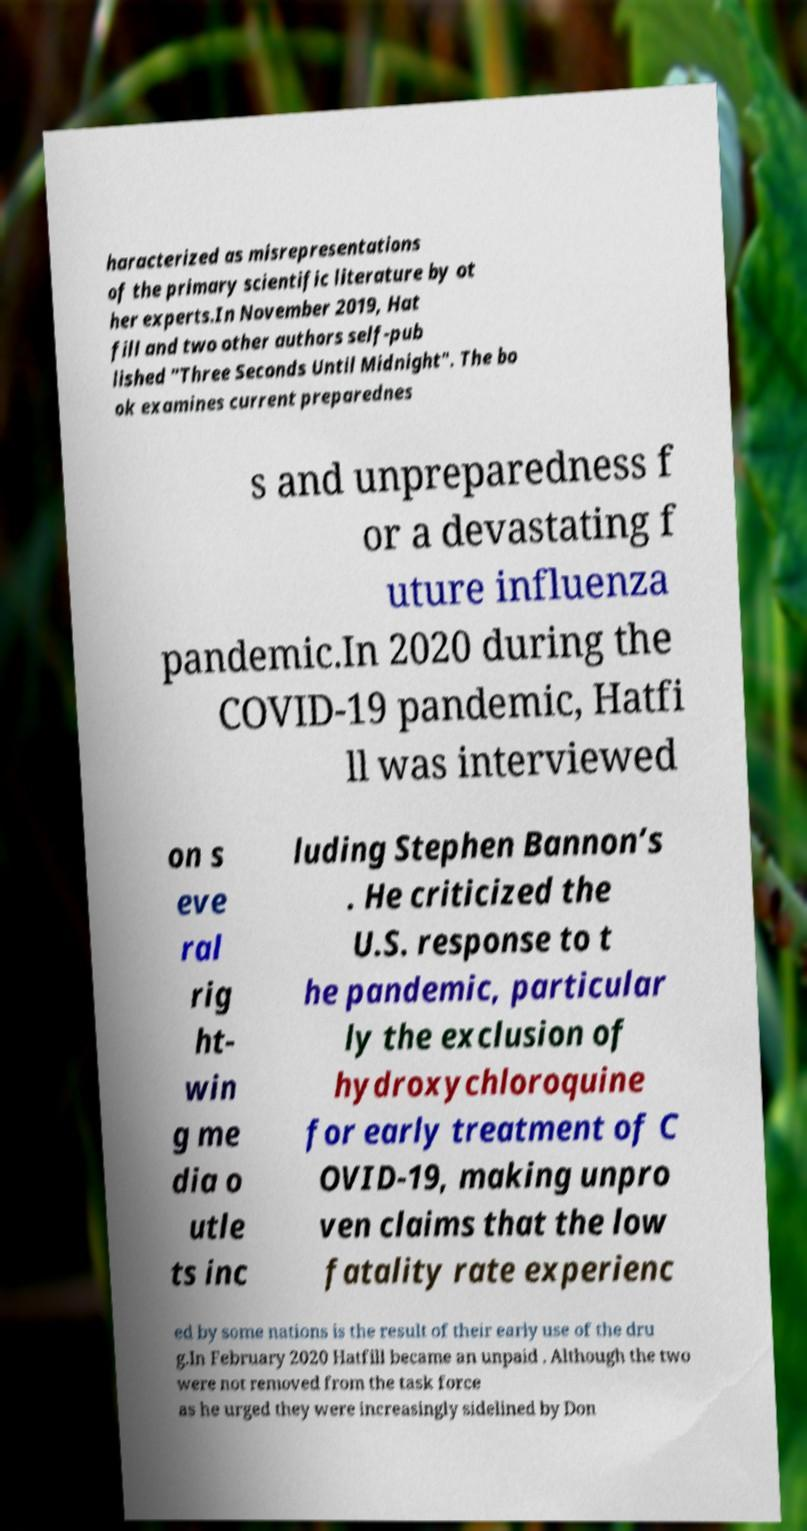Could you assist in decoding the text presented in this image and type it out clearly? haracterized as misrepresentations of the primary scientific literature by ot her experts.In November 2019, Hat fill and two other authors self-pub lished "Three Seconds Until Midnight". The bo ok examines current preparednes s and unpreparedness f or a devastating f uture influenza pandemic.In 2020 during the COVID-19 pandemic, Hatfi ll was interviewed on s eve ral rig ht- win g me dia o utle ts inc luding Stephen Bannon’s . He criticized the U.S. response to t he pandemic, particular ly the exclusion of hydroxychloroquine for early treatment of C OVID-19, making unpro ven claims that the low fatality rate experienc ed by some nations is the result of their early use of the dru g.In February 2020 Hatfill became an unpaid . Although the two were not removed from the task force as he urged they were increasingly sidelined by Don 